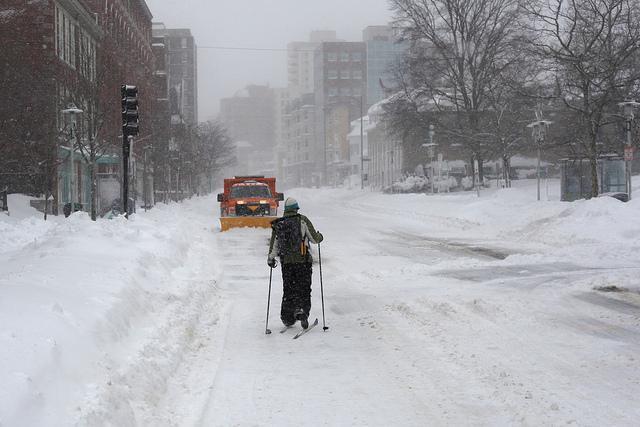How many slices of pizza is on the plate?
Give a very brief answer. 0. 